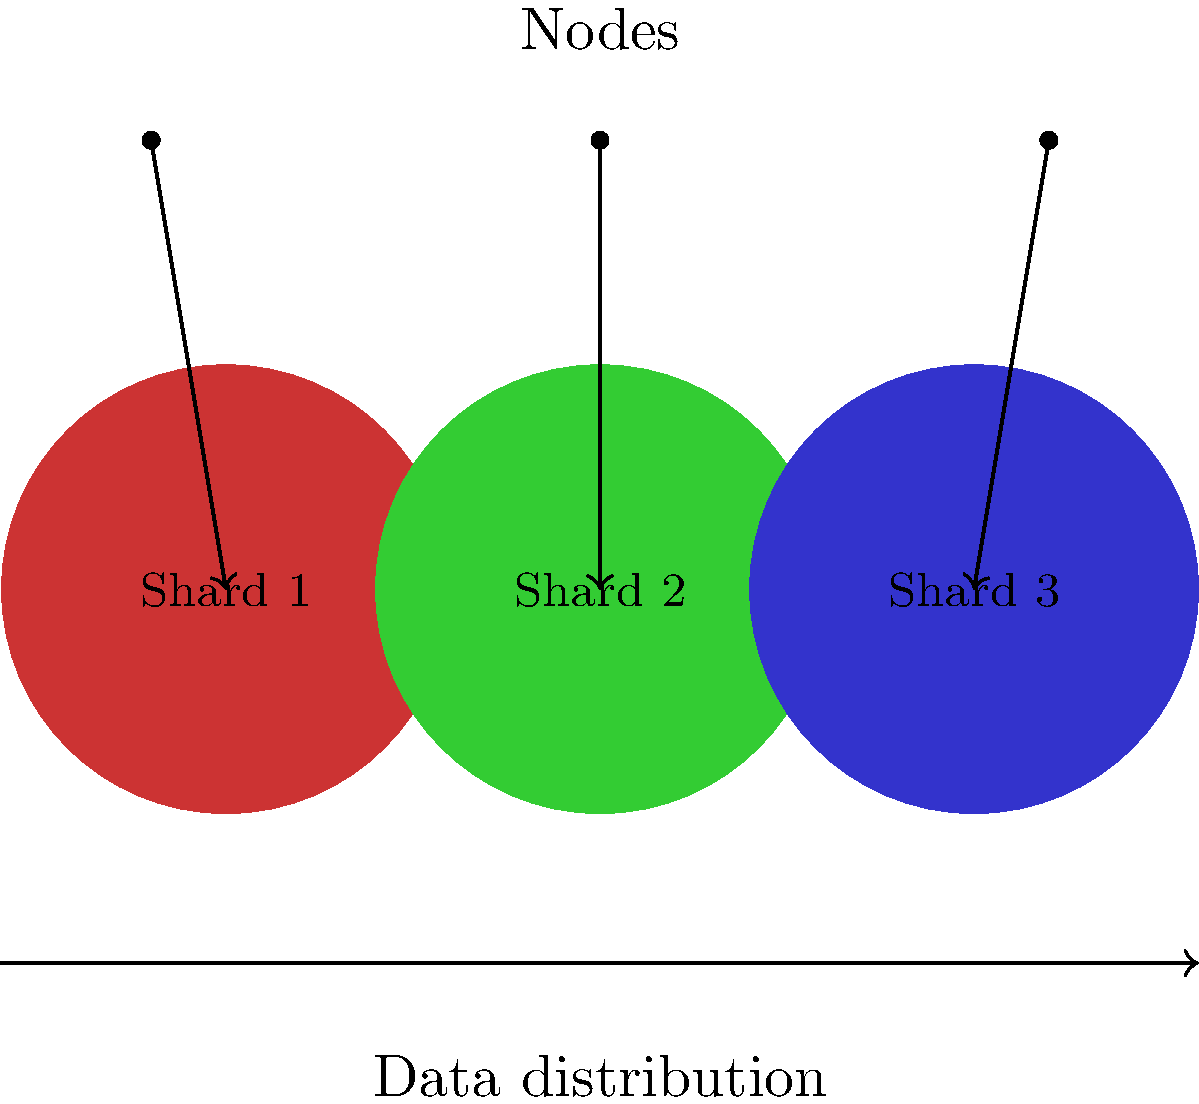In a distributed system employing sharding for improved scalability, what is the primary challenge when implementing cross-shard transactions, and how does it impact the overall system performance? Refer to the diagram showing a basic sharding setup with three shards and corresponding nodes. To understand the challenge of cross-shard transactions in a sharded distributed system, let's break down the concept and its implications:

1. Sharding basics:
   - The diagram shows a distributed system divided into three shards, each managed by a separate node.
   - Sharding is a technique used to horizontally partition data across multiple servers or shards.

2. Purpose of sharding:
   - Improves scalability by distributing data and processing load.
   - Allows for parallel processing of transactions within each shard.

3. Cross-shard transactions:
   - Occur when a transaction involves data from multiple shards.
   - In the diagram, this would mean a transaction affecting data in two or more of the colored shards.

4. Primary challenge:
   - Maintaining consistency and atomicity across multiple shards.
   - Ensuring that all parts of a transaction are completed successfully or none at all.

5. Impact on performance:
   - Increased latency due to communication between shards.
   - Additional overhead for coordination and consensus protocols.
   - Potential for deadlocks or livelocks if not managed properly.

6. Consistency vs. Performance trade-off:
   - Stronger consistency guarantees often lead to lower performance.
   - Relaxed consistency can improve performance but may introduce complexities in application logic.

7. Scalability implications:
   - As the number of shards increases, the probability of cross-shard transactions also increases.
   - This can potentially limit the scalability benefits of sharding.

8. Mitigation strategies:
   - Careful data partitioning to minimize cross-shard transactions.
   - Implementing efficient cross-shard communication protocols.
   - Using techniques like two-phase commit or distributed sagas for managing cross-shard transactions.

The primary challenge in implementing cross-shard transactions is maintaining consistency while minimizing the performance impact on the overall system.
Answer: Maintaining consistency across shards while minimizing performance overhead. 